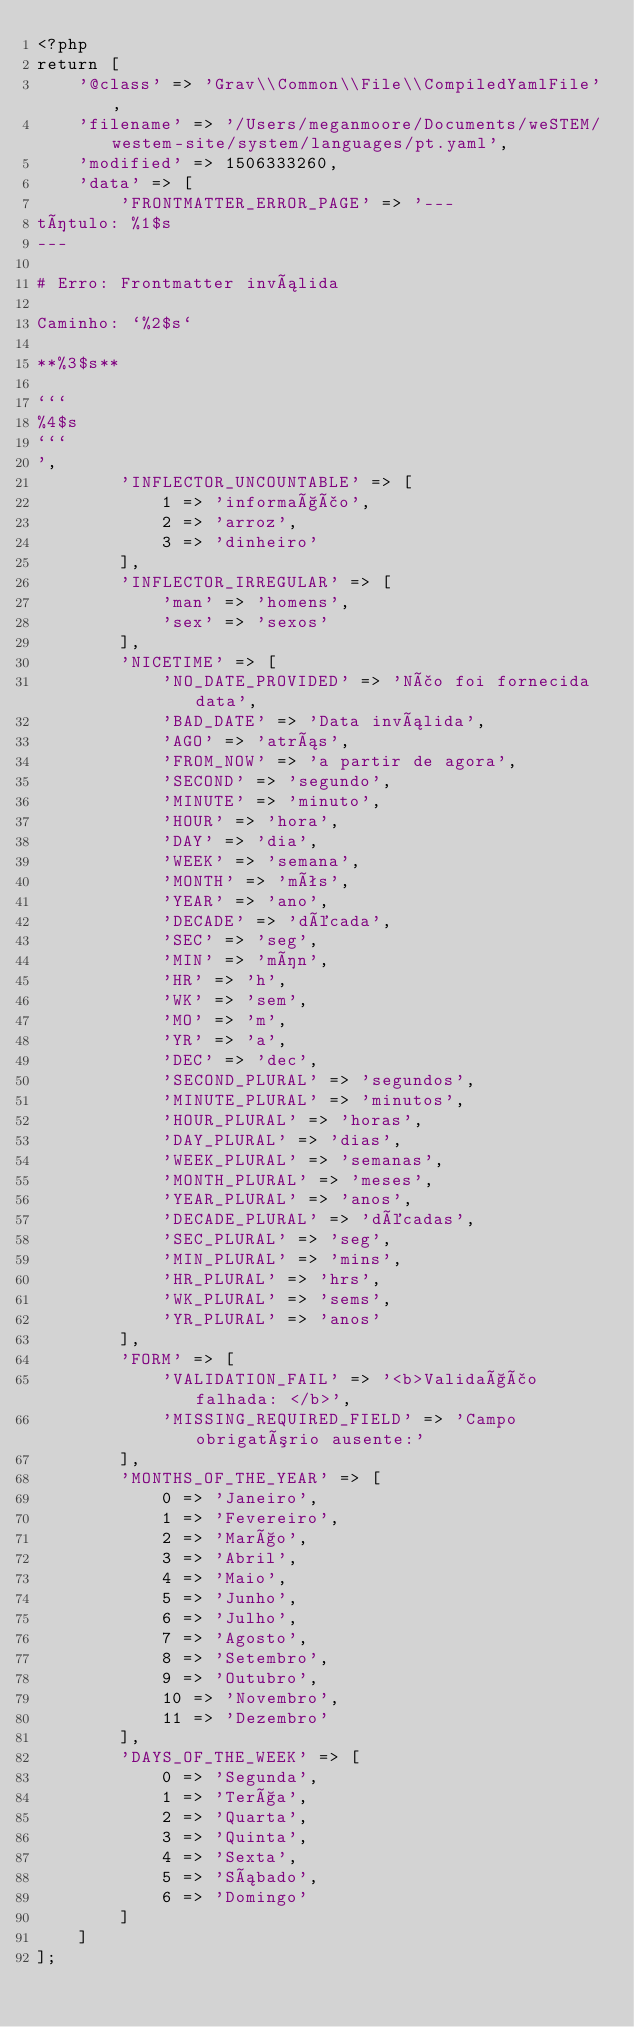Convert code to text. <code><loc_0><loc_0><loc_500><loc_500><_PHP_><?php
return [
    '@class' => 'Grav\\Common\\File\\CompiledYamlFile',
    'filename' => '/Users/meganmoore/Documents/weSTEM/westem-site/system/languages/pt.yaml',
    'modified' => 1506333260,
    'data' => [
        'FRONTMATTER_ERROR_PAGE' => '---
título: %1$s
---

# Erro: Frontmatter inválida

Caminho: `%2$s`

**%3$s**

```
%4$s
```
',
        'INFLECTOR_UNCOUNTABLE' => [
            1 => 'informação',
            2 => 'arroz',
            3 => 'dinheiro'
        ],
        'INFLECTOR_IRREGULAR' => [
            'man' => 'homens',
            'sex' => 'sexos'
        ],
        'NICETIME' => [
            'NO_DATE_PROVIDED' => 'Não foi fornecida data',
            'BAD_DATE' => 'Data inválida',
            'AGO' => 'atrás',
            'FROM_NOW' => 'a partir de agora',
            'SECOND' => 'segundo',
            'MINUTE' => 'minuto',
            'HOUR' => 'hora',
            'DAY' => 'dia',
            'WEEK' => 'semana',
            'MONTH' => 'mês',
            'YEAR' => 'ano',
            'DECADE' => 'década',
            'SEC' => 'seg',
            'MIN' => 'mín',
            'HR' => 'h',
            'WK' => 'sem',
            'MO' => 'm',
            'YR' => 'a',
            'DEC' => 'dec',
            'SECOND_PLURAL' => 'segundos',
            'MINUTE_PLURAL' => 'minutos',
            'HOUR_PLURAL' => 'horas',
            'DAY_PLURAL' => 'dias',
            'WEEK_PLURAL' => 'semanas',
            'MONTH_PLURAL' => 'meses',
            'YEAR_PLURAL' => 'anos',
            'DECADE_PLURAL' => 'décadas',
            'SEC_PLURAL' => 'seg',
            'MIN_PLURAL' => 'mins',
            'HR_PLURAL' => 'hrs',
            'WK_PLURAL' => 'sems',
            'YR_PLURAL' => 'anos'
        ],
        'FORM' => [
            'VALIDATION_FAIL' => '<b>Validação falhada: </b>',
            'MISSING_REQUIRED_FIELD' => 'Campo obrigatório ausente:'
        ],
        'MONTHS_OF_THE_YEAR' => [
            0 => 'Janeiro',
            1 => 'Fevereiro',
            2 => 'Março',
            3 => 'Abril',
            4 => 'Maio',
            5 => 'Junho',
            6 => 'Julho',
            7 => 'Agosto',
            8 => 'Setembro',
            9 => 'Outubro',
            10 => 'Novembro',
            11 => 'Dezembro'
        ],
        'DAYS_OF_THE_WEEK' => [
            0 => 'Segunda',
            1 => 'Terça',
            2 => 'Quarta',
            3 => 'Quinta',
            4 => 'Sexta',
            5 => 'Sábado',
            6 => 'Domingo'
        ]
    ]
];
</code> 